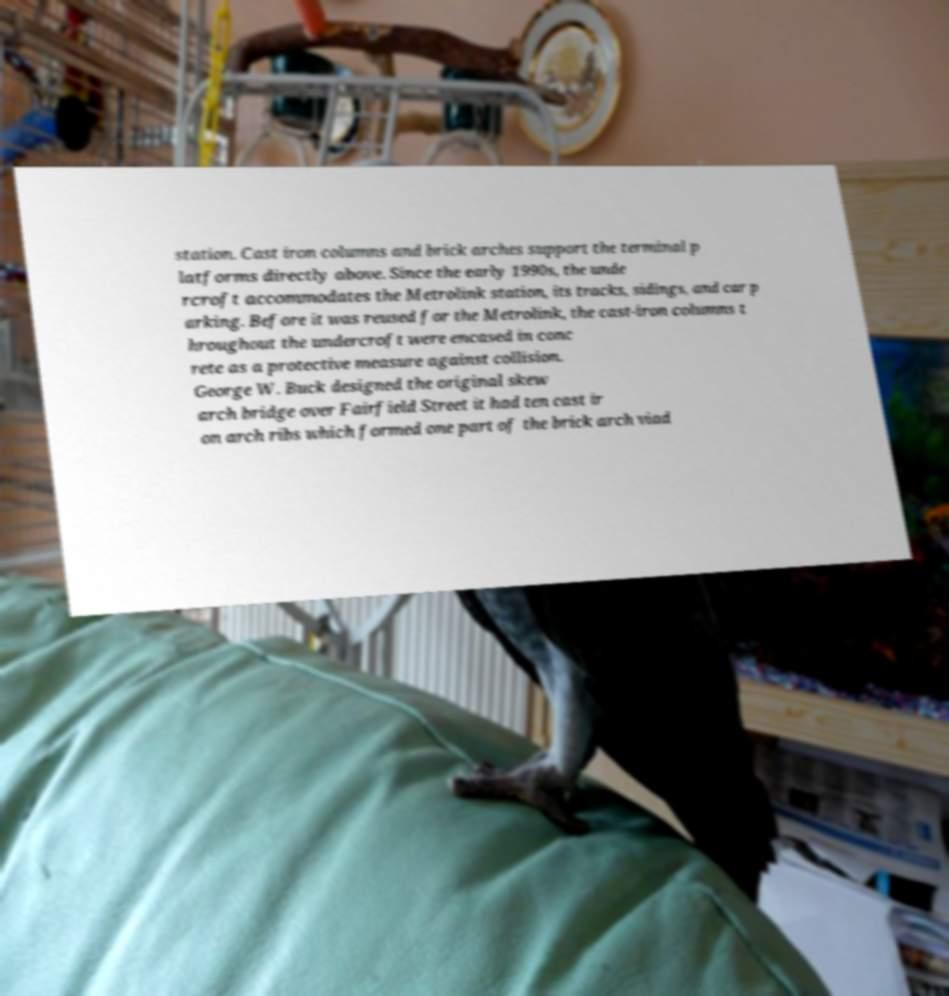Please identify and transcribe the text found in this image. station. Cast iron columns and brick arches support the terminal p latforms directly above. Since the early 1990s, the unde rcroft accommodates the Metrolink station, its tracks, sidings, and car p arking. Before it was reused for the Metrolink, the cast-iron columns t hroughout the undercroft were encased in conc rete as a protective measure against collision. George W. Buck designed the original skew arch bridge over Fairfield Street it had ten cast ir on arch ribs which formed one part of the brick arch viad 